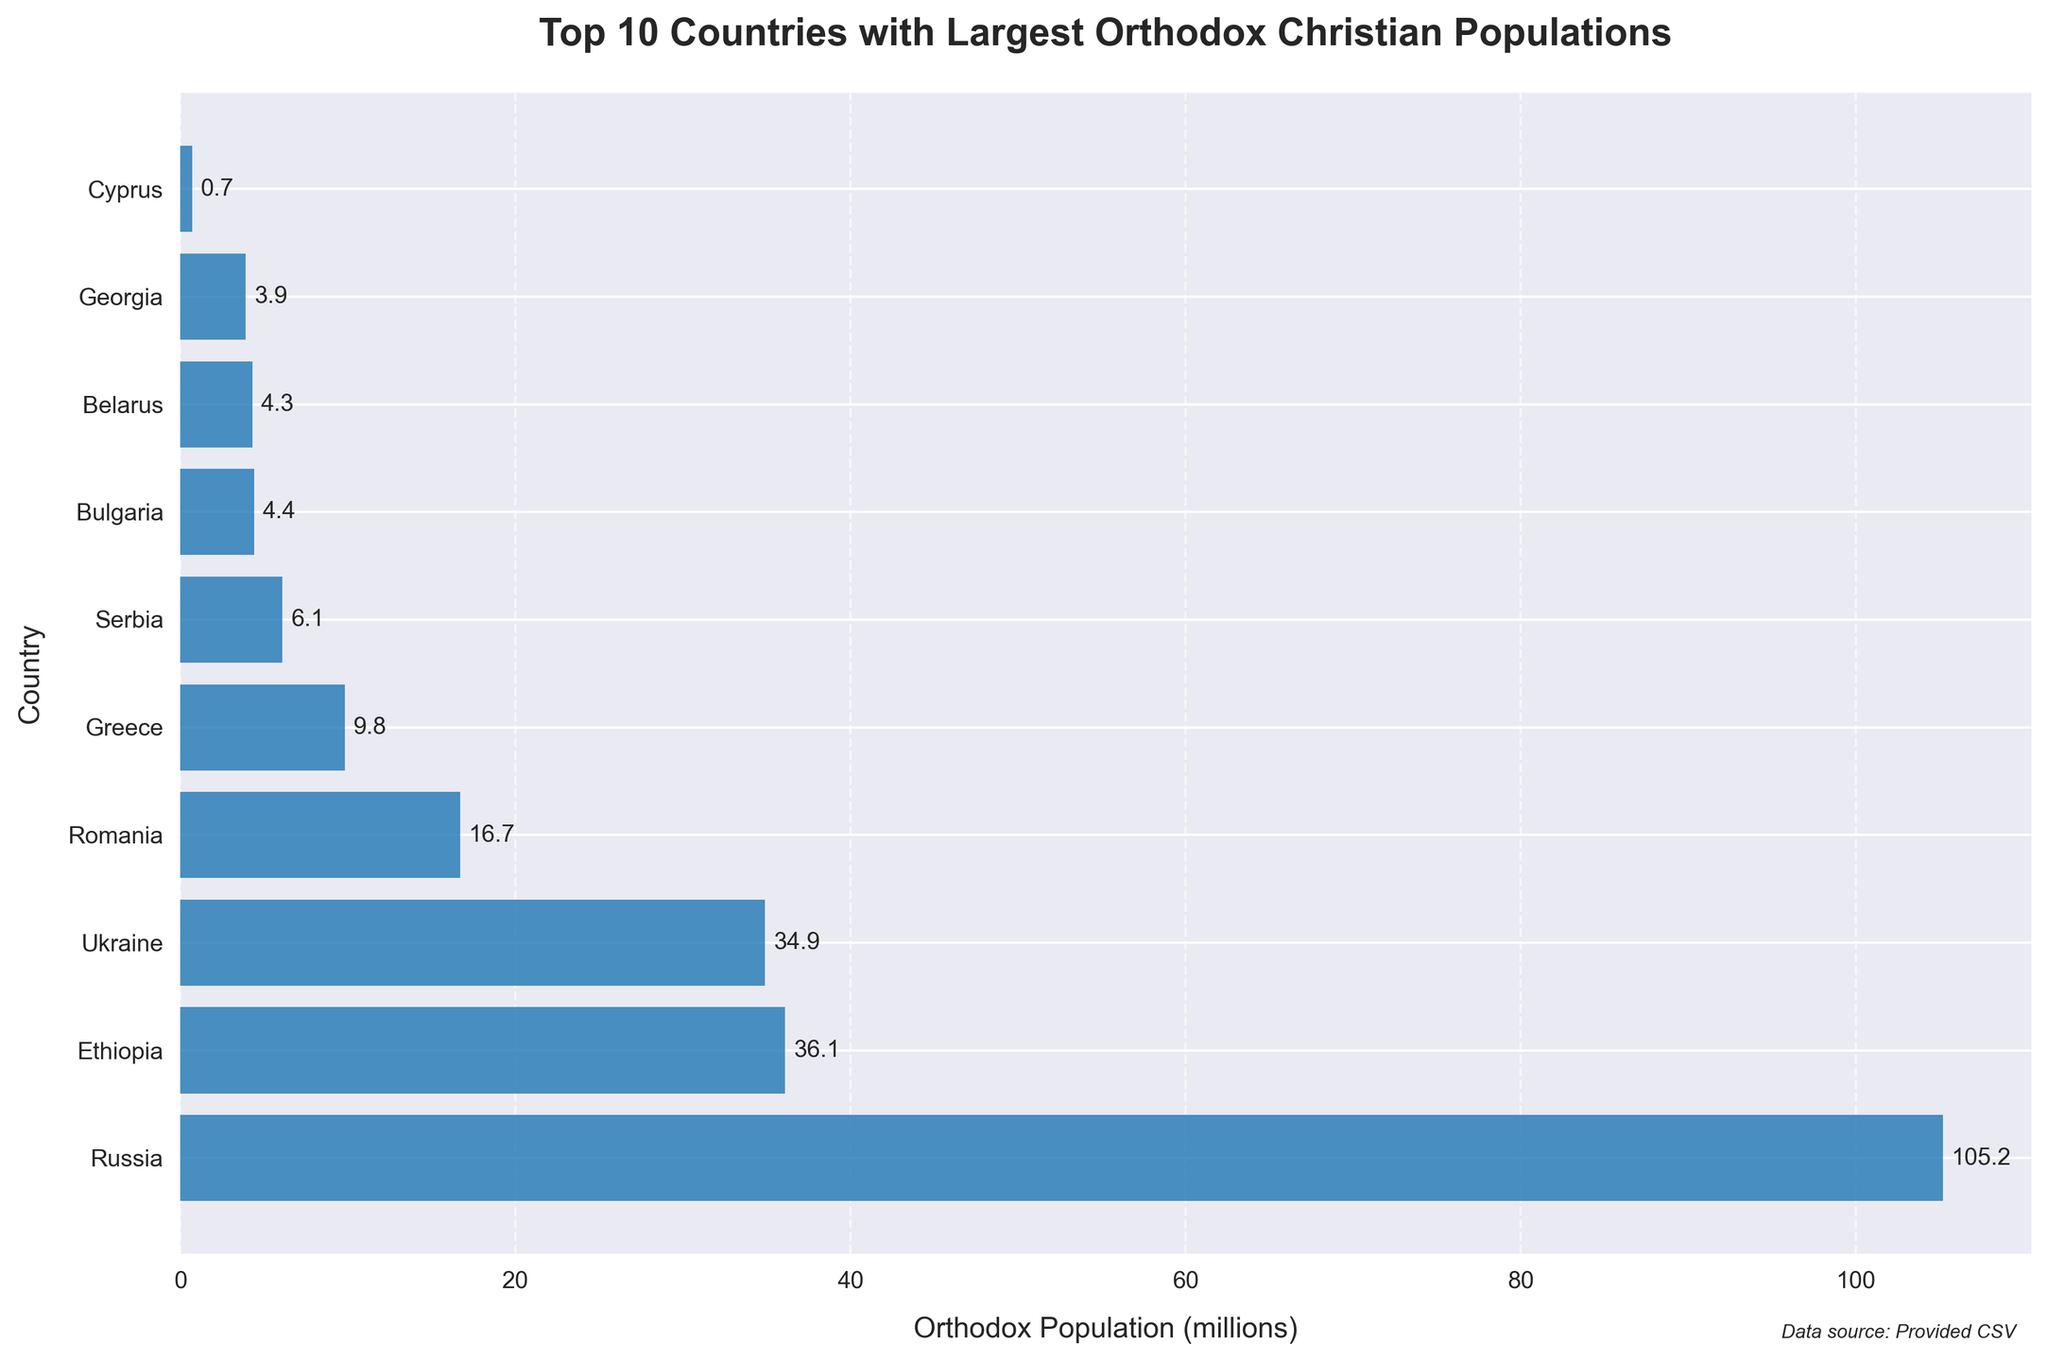How many countries have an Orthodox Christian population greater than 10 million? To determine this, you need to count the number of bars on the chart that represent populations exceeding 10 million. By referring to the figure, you see that Russia, Ethiopia, and Ukraine exceed this threshold.
Answer: 3 Which country has the smallest Orthodox Christian population among the top 10 listed? This requires identifying the shortest bar in the chart. From the figure, Cyprus has the smallest population in the top 10, at 0.7 million.
Answer: Cyprus What is the total Orthodox Christian population of the top 3 countries combined? Sum the Orthodox populations of Russia, Ethiopia, and Ukraine, which are 105.2, 36.1, and 34.9 million, respectively. The total is 105.2 + 36.1 + 34.9 = 176.2 million.
Answer: 176.2 million Which two countries have a total Orthodox Christian population roughly equal to that of Greece? Referring to the figure, Greece has an Orthodox population of 9.8 million. By combining Serbia (6.1 million) and Bulgaria (4.4 million), we get 6.1 + 4.4 = 10.5 million, which is roughly equal to Greece's population.
Answer: Serbia and Bulgaria How much larger is Romania's Orthodox Christian population compared to Belarus'? Romania's population is 16.7 million, and Belarus' is 4.3 million. The difference is computed as 16.7 - 4.3 = 12.4 million.
Answer: 12.4 million What is the average Orthodox Christian population of the top 5 countries? To find this, sum the populations of the top 5 countries (Russia, Ethiopia, Ukraine, Romania, Greece) and then divide by 5. The populations are 105.2, 36.1, 34.9, 16.7, and 9.8 respectively. The sum is 105.2 + 36.1 + 34.9 + 16.7 + 9.8 = 202.7 million. The average is 202.7 / 5 = 40.54 million.
Answer: 40.54 million Which country ranks fourth in Orthodox Christian population? From the chart, after Russia, Ethiopia, and Ukraine, the next bar represents Romania, making it the country with the fourth largest Orthodox Christian population.
Answer: Romania How many more million Orthodox Christians are there in Ukraine than in Greece? Ukraine has 34.9 million, and Greece has 9.8 million. The difference is 34.9 - 9.8 = 25.1 million.
Answer: 25.1 Is the combined population of Bulgaria and Georgia greater than that of Serbia? Bulgaria has 4.4 million and Georgia has 3.9 million. Adding them together gives 4.4 + 3.9 = 8.3 million. Serbia has 6.1 million, so 8.3 million is indeed greater than 6.1 million.
Answer: Yes 